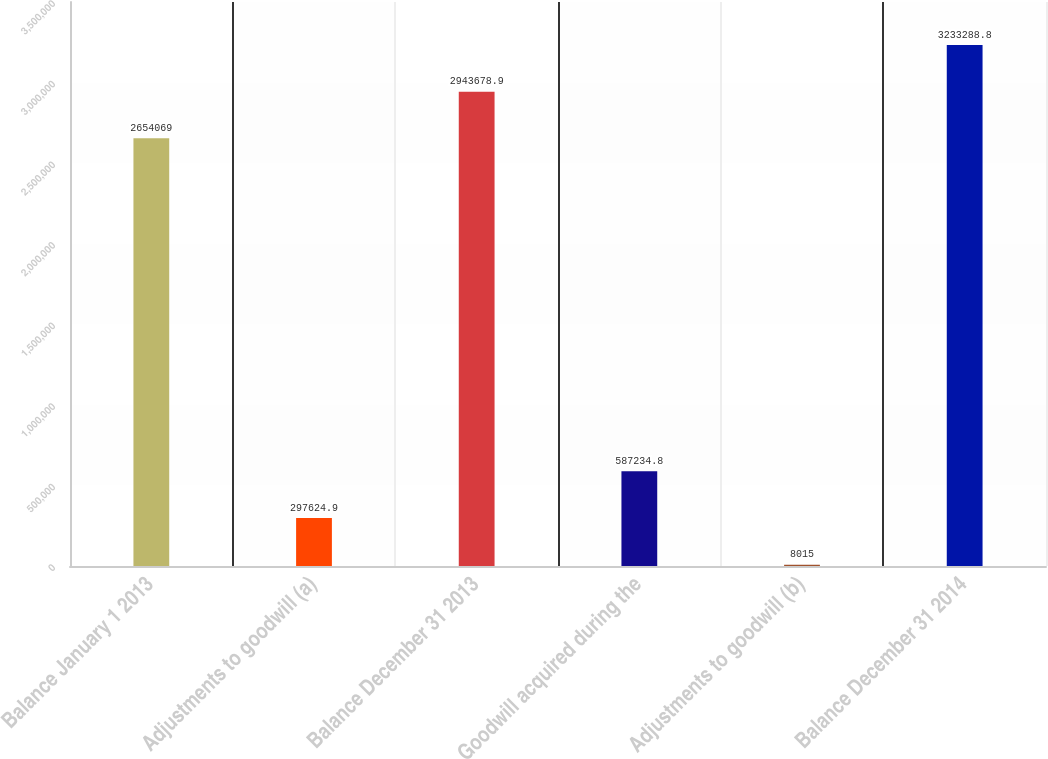<chart> <loc_0><loc_0><loc_500><loc_500><bar_chart><fcel>Balance January 1 2013<fcel>Adjustments to goodwill (a)<fcel>Balance December 31 2013<fcel>Goodwill acquired during the<fcel>Adjustments to goodwill (b)<fcel>Balance December 31 2014<nl><fcel>2.65407e+06<fcel>297625<fcel>2.94368e+06<fcel>587235<fcel>8015<fcel>3.23329e+06<nl></chart> 